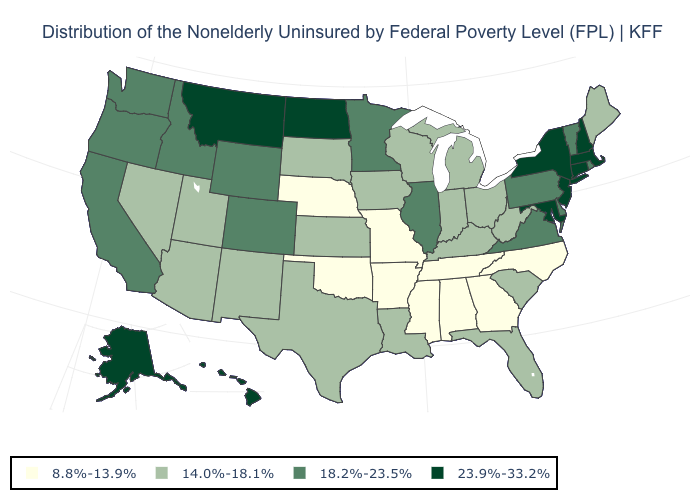Name the states that have a value in the range 14.0%-18.1%?
Concise answer only. Arizona, Florida, Indiana, Iowa, Kansas, Kentucky, Louisiana, Maine, Michigan, Nevada, New Mexico, Ohio, South Carolina, South Dakota, Texas, Utah, West Virginia, Wisconsin. Is the legend a continuous bar?
Concise answer only. No. Name the states that have a value in the range 23.9%-33.2%?
Give a very brief answer. Alaska, Connecticut, Hawaii, Maryland, Massachusetts, Montana, New Hampshire, New Jersey, New York, North Dakota. Among the states that border West Virginia , does Ohio have the lowest value?
Quick response, please. Yes. Does South Carolina have a lower value than Illinois?
Keep it brief. Yes. What is the highest value in the USA?
Short answer required. 23.9%-33.2%. Name the states that have a value in the range 23.9%-33.2%?
Give a very brief answer. Alaska, Connecticut, Hawaii, Maryland, Massachusetts, Montana, New Hampshire, New Jersey, New York, North Dakota. Name the states that have a value in the range 18.2%-23.5%?
Keep it brief. California, Colorado, Delaware, Idaho, Illinois, Minnesota, Oregon, Pennsylvania, Rhode Island, Vermont, Virginia, Washington, Wyoming. Name the states that have a value in the range 18.2%-23.5%?
Write a very short answer. California, Colorado, Delaware, Idaho, Illinois, Minnesota, Oregon, Pennsylvania, Rhode Island, Vermont, Virginia, Washington, Wyoming. What is the value of Kentucky?
Quick response, please. 14.0%-18.1%. Does Colorado have the highest value in the West?
Give a very brief answer. No. Which states have the highest value in the USA?
Give a very brief answer. Alaska, Connecticut, Hawaii, Maryland, Massachusetts, Montana, New Hampshire, New Jersey, New York, North Dakota. Which states have the lowest value in the USA?
Short answer required. Alabama, Arkansas, Georgia, Mississippi, Missouri, Nebraska, North Carolina, Oklahoma, Tennessee. What is the lowest value in the USA?
Keep it brief. 8.8%-13.9%. What is the value of Nebraska?
Answer briefly. 8.8%-13.9%. 